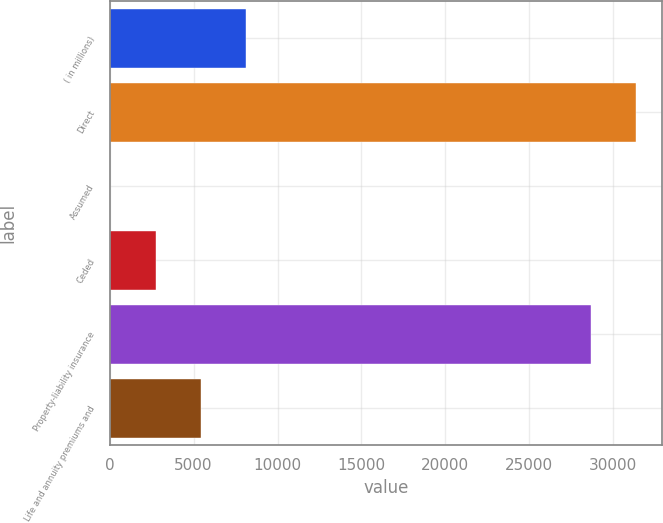Convert chart. <chart><loc_0><loc_0><loc_500><loc_500><bar_chart><fcel>( in millions)<fcel>Direct<fcel>Assumed<fcel>Ceded<fcel>Property-liability insurance<fcel>Life and annuity premiums and<nl><fcel>8122.7<fcel>31358.8<fcel>41<fcel>2734.9<fcel>28664.9<fcel>5428.8<nl></chart> 